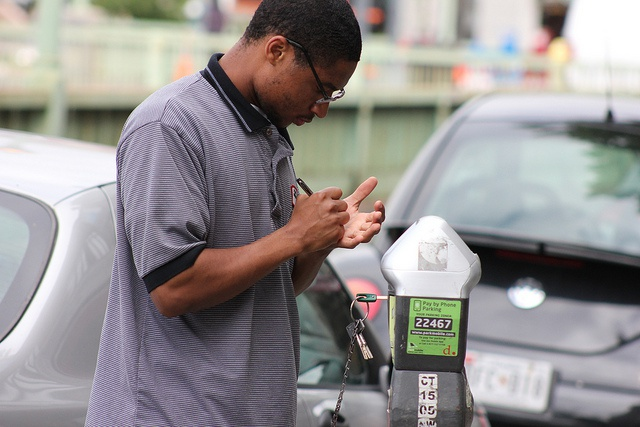Describe the objects in this image and their specific colors. I can see people in lightgray, gray, black, darkgray, and maroon tones, car in lightgray, darkgray, black, and gray tones, car in lightgray, darkgray, and white tones, and parking meter in lightgray, gray, black, and darkgray tones in this image. 